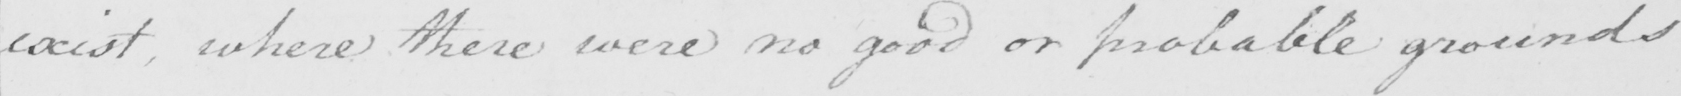What text is written in this handwritten line? exist where there were no good or probable grounds 